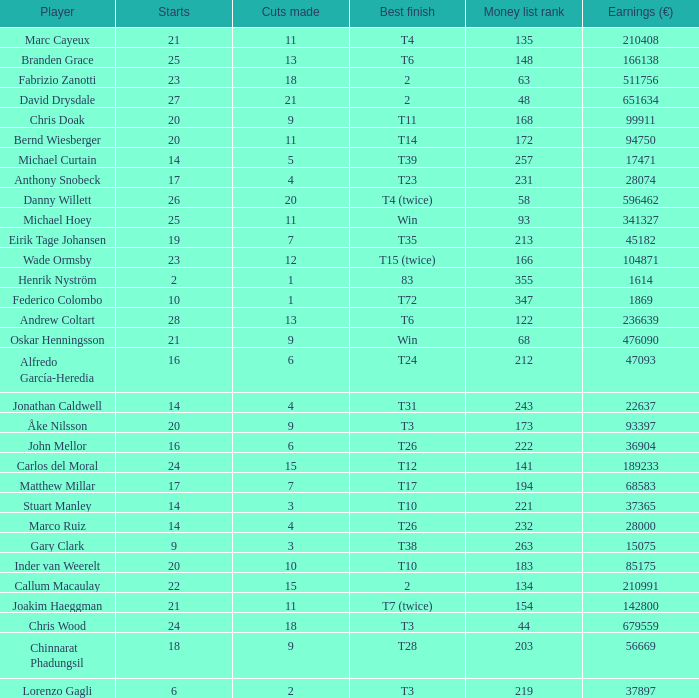Would you mind parsing the complete table? {'header': ['Player', 'Starts', 'Cuts made', 'Best finish', 'Money list rank', 'Earnings (€)'], 'rows': [['Marc Cayeux', '21', '11', 'T4', '135', '210408'], ['Branden Grace', '25', '13', 'T6', '148', '166138'], ['Fabrizio Zanotti', '23', '18', '2', '63', '511756'], ['David Drysdale', '27', '21', '2', '48', '651634'], ['Chris Doak', '20', '9', 'T11', '168', '99911'], ['Bernd Wiesberger', '20', '11', 'T14', '172', '94750'], ['Michael Curtain', '14', '5', 'T39', '257', '17471'], ['Anthony Snobeck', '17', '4', 'T23', '231', '28074'], ['Danny Willett', '26', '20', 'T4 (twice)', '58', '596462'], ['Michael Hoey', '25', '11', 'Win', '93', '341327'], ['Eirik Tage Johansen', '19', '7', 'T35', '213', '45182'], ['Wade Ormsby', '23', '12', 'T15 (twice)', '166', '104871'], ['Henrik Nyström', '2', '1', '83', '355', '1614'], ['Federico Colombo', '10', '1', 'T72', '347', '1869'], ['Andrew Coltart', '28', '13', 'T6', '122', '236639'], ['Oskar Henningsson', '21', '9', 'Win', '68', '476090'], ['Alfredo García-Heredia', '16', '6', 'T24', '212', '47093'], ['Jonathan Caldwell', '14', '4', 'T31', '243', '22637'], ['Åke Nilsson', '20', '9', 'T3', '173', '93397'], ['John Mellor', '16', '6', 'T26', '222', '36904'], ['Carlos del Moral', '24', '15', 'T12', '141', '189233'], ['Matthew Millar', '17', '7', 'T17', '194', '68583'], ['Stuart Manley', '14', '3', 'T10', '221', '37365'], ['Marco Ruiz', '14', '4', 'T26', '232', '28000'], ['Gary Clark', '9', '3', 'T38', '263', '15075'], ['Inder van Weerelt', '20', '10', 'T10', '183', '85175'], ['Callum Macaulay', '22', '15', '2', '134', '210991'], ['Joakim Haeggman', '21', '11', 'T7 (twice)', '154', '142800'], ['Chris Wood', '24', '18', 'T3', '44', '679559'], ['Chinnarat Phadungsil', '18', '9', 'T28', '203', '56669'], ['Lorenzo Gagli', '6', '2', 'T3', '219', '37897']]} How many earnings values are associated with players who had a best finish of T38? 1.0. 